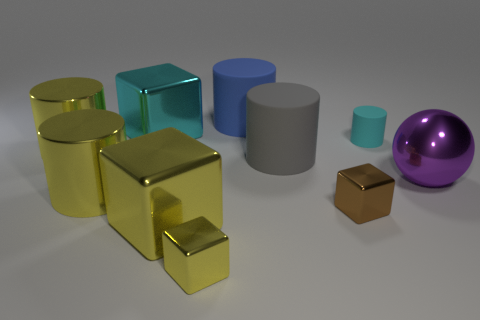What number of other things are there of the same shape as the blue thing?
Provide a short and direct response. 4. The metal thing behind the yellow metallic cylinder that is behind the ball is what shape?
Offer a terse response. Cube. Are the tiny object that is behind the big purple ball and the gray cylinder made of the same material?
Keep it short and to the point. Yes. Are there an equal number of cylinders that are in front of the large gray rubber thing and tiny cyan things that are to the right of the purple sphere?
Your answer should be very brief. No. What material is the block that is the same color as the tiny rubber thing?
Provide a succinct answer. Metal. There is a shiny thing that is to the right of the small brown metallic block; what number of small matte cylinders are in front of it?
Ensure brevity in your answer.  0. There is a matte thing to the right of the small brown metal cube; is it the same color as the big metallic thing on the right side of the big blue thing?
Provide a short and direct response. No. There is a yellow cube that is the same size as the cyan rubber cylinder; what material is it?
Offer a very short reply. Metal. There is a big metallic thing that is to the right of the brown cube that is on the right side of the big block that is behind the cyan cylinder; what is its shape?
Make the answer very short. Sphere. What is the shape of the other matte thing that is the same size as the brown object?
Keep it short and to the point. Cylinder. 